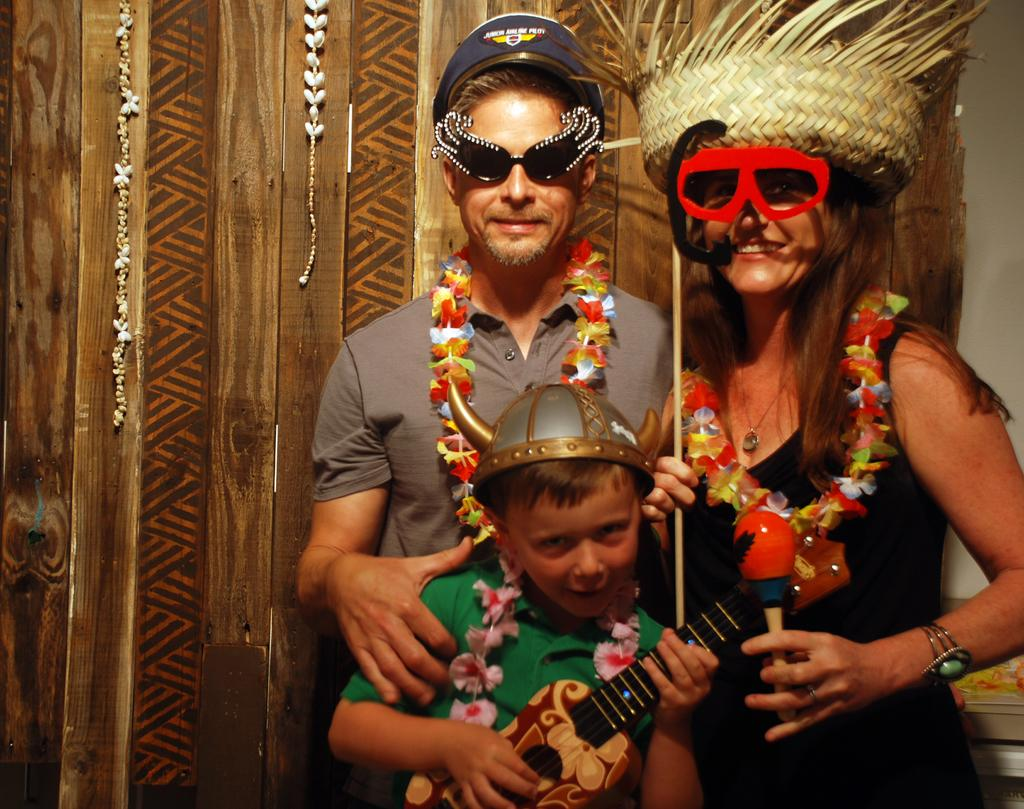How many people are in the image? There are three people in the image. What can be observed about the attire of each person? Each person is wearing a different costume. What type of cap is the person on the left wearing in the image? There is no cap visible in the image; the focus is on the different costumes worn by each person. 